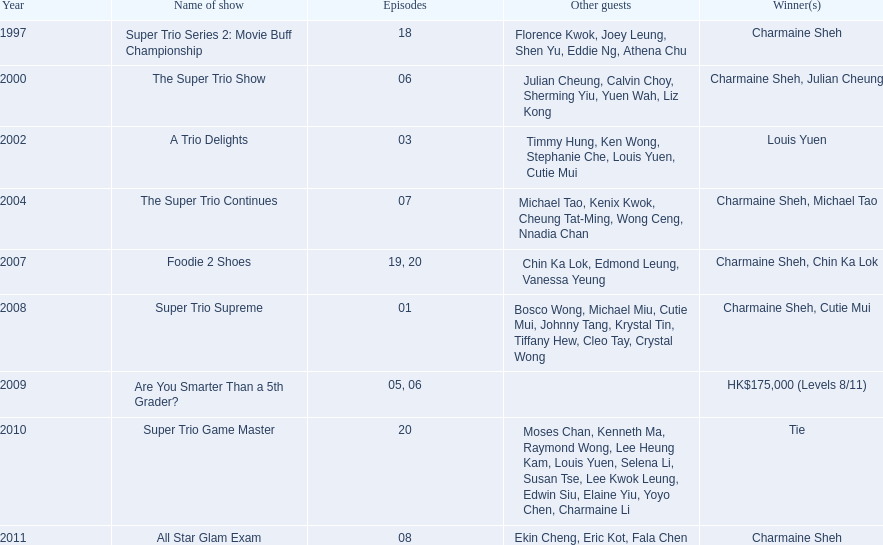What is the number of tv shows that charmaine sheh has appeared on? 9. 